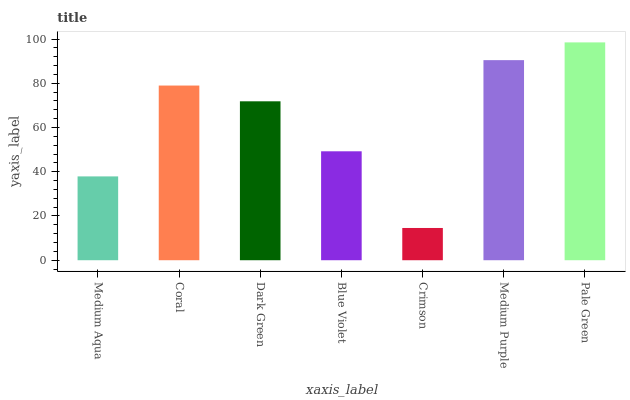Is Coral the minimum?
Answer yes or no. No. Is Coral the maximum?
Answer yes or no. No. Is Coral greater than Medium Aqua?
Answer yes or no. Yes. Is Medium Aqua less than Coral?
Answer yes or no. Yes. Is Medium Aqua greater than Coral?
Answer yes or no. No. Is Coral less than Medium Aqua?
Answer yes or no. No. Is Dark Green the high median?
Answer yes or no. Yes. Is Dark Green the low median?
Answer yes or no. Yes. Is Coral the high median?
Answer yes or no. No. Is Medium Purple the low median?
Answer yes or no. No. 